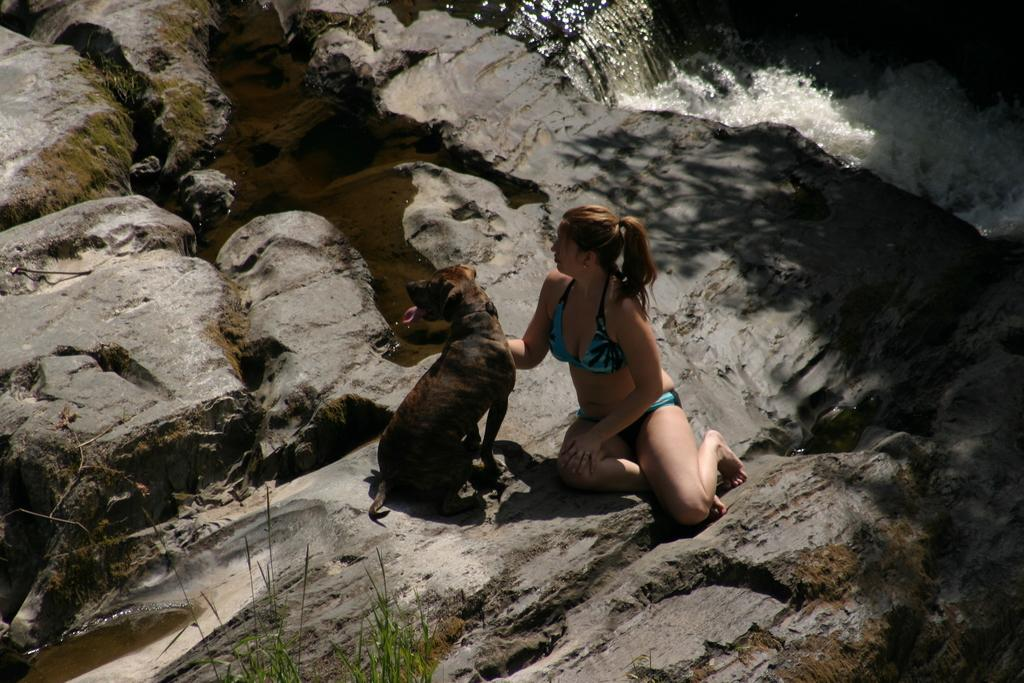Who is present in the image? There is a woman in the image. What other living creature can be seen in the image? There is a dog in the image. What is the dog doing in the image? The dog is looking at somewhere. What can be seen on the right side of the image? There is a flow of water on the right side of the image. What type of fuel is being used by the bear in the image? There is no bear present in the image, so the question about fuel cannot be answered. 